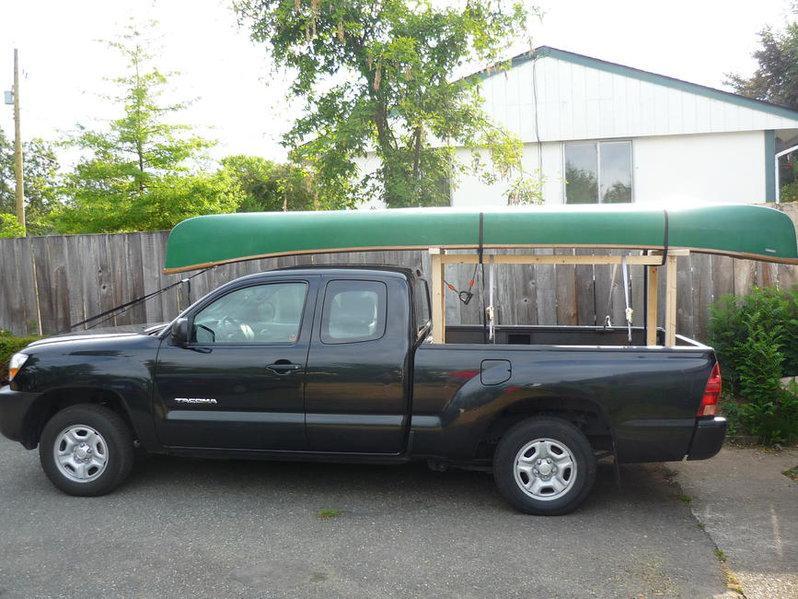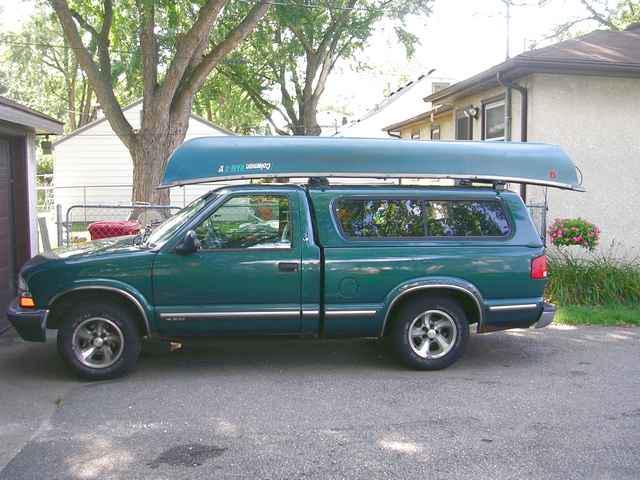The first image is the image on the left, the second image is the image on the right. For the images displayed, is the sentence "One of the boats is green." factually correct? Answer yes or no. Yes. 